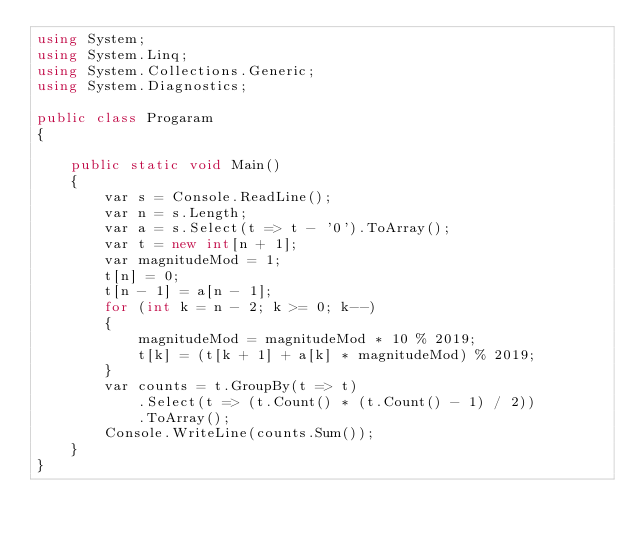<code> <loc_0><loc_0><loc_500><loc_500><_C#_>using System;
using System.Linq;
using System.Collections.Generic;
using System.Diagnostics;

public class Progaram
{

    public static void Main()
    {
        var s = Console.ReadLine();
        var n = s.Length;
        var a = s.Select(t => t - '0').ToArray();
        var t = new int[n + 1];
        var magnitudeMod = 1;
        t[n] = 0;
        t[n - 1] = a[n - 1];
        for (int k = n - 2; k >= 0; k--)
        {
            magnitudeMod = magnitudeMod * 10 % 2019;
            t[k] = (t[k + 1] + a[k] * magnitudeMod) % 2019;
        }
        var counts = t.GroupBy(t => t)
            .Select(t => (t.Count() * (t.Count() - 1) / 2))
            .ToArray();
        Console.WriteLine(counts.Sum());
    }
}</code> 